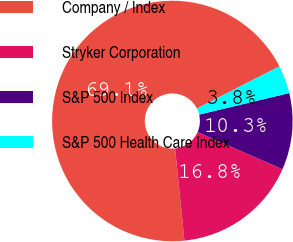Convert chart to OTSL. <chart><loc_0><loc_0><loc_500><loc_500><pie_chart><fcel>Company / Index<fcel>Stryker Corporation<fcel>S&P 500 Index<fcel>S&P 500 Health Care Index<nl><fcel>69.1%<fcel>16.83%<fcel>10.3%<fcel>3.77%<nl></chart> 